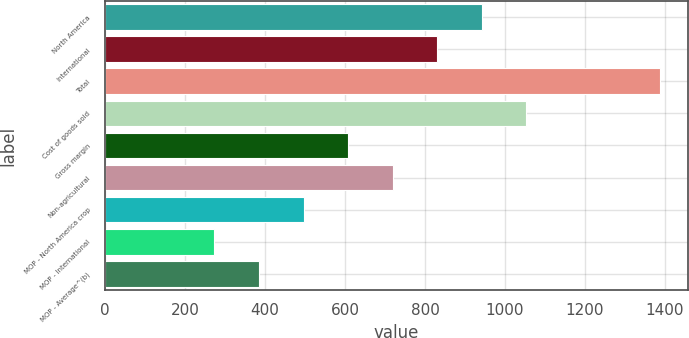Convert chart. <chart><loc_0><loc_0><loc_500><loc_500><bar_chart><fcel>North America<fcel>International<fcel>Total<fcel>Cost of goods sold<fcel>Gross margin<fcel>Non-agricultural<fcel>MOP - North America crop<fcel>MOP - International<fcel>MOP - Average^(b)<nl><fcel>941.92<fcel>830.6<fcel>1387.2<fcel>1053.24<fcel>607.96<fcel>719.28<fcel>496.64<fcel>274<fcel>385.32<nl></chart> 